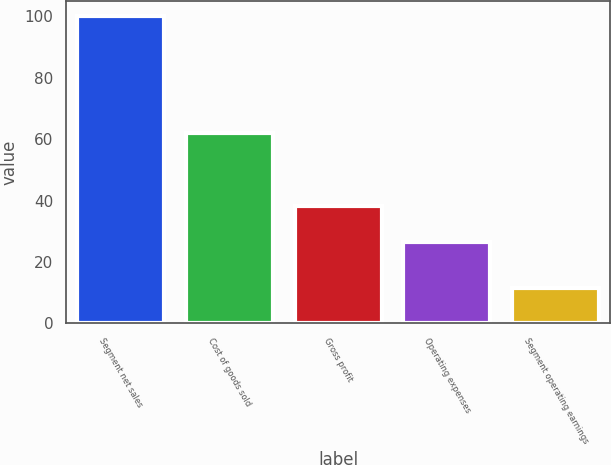<chart> <loc_0><loc_0><loc_500><loc_500><bar_chart><fcel>Segment net sales<fcel>Cost of goods sold<fcel>Gross profit<fcel>Operating expenses<fcel>Segment operating earnings<nl><fcel>100<fcel>61.9<fcel>38.1<fcel>26.5<fcel>11.6<nl></chart> 